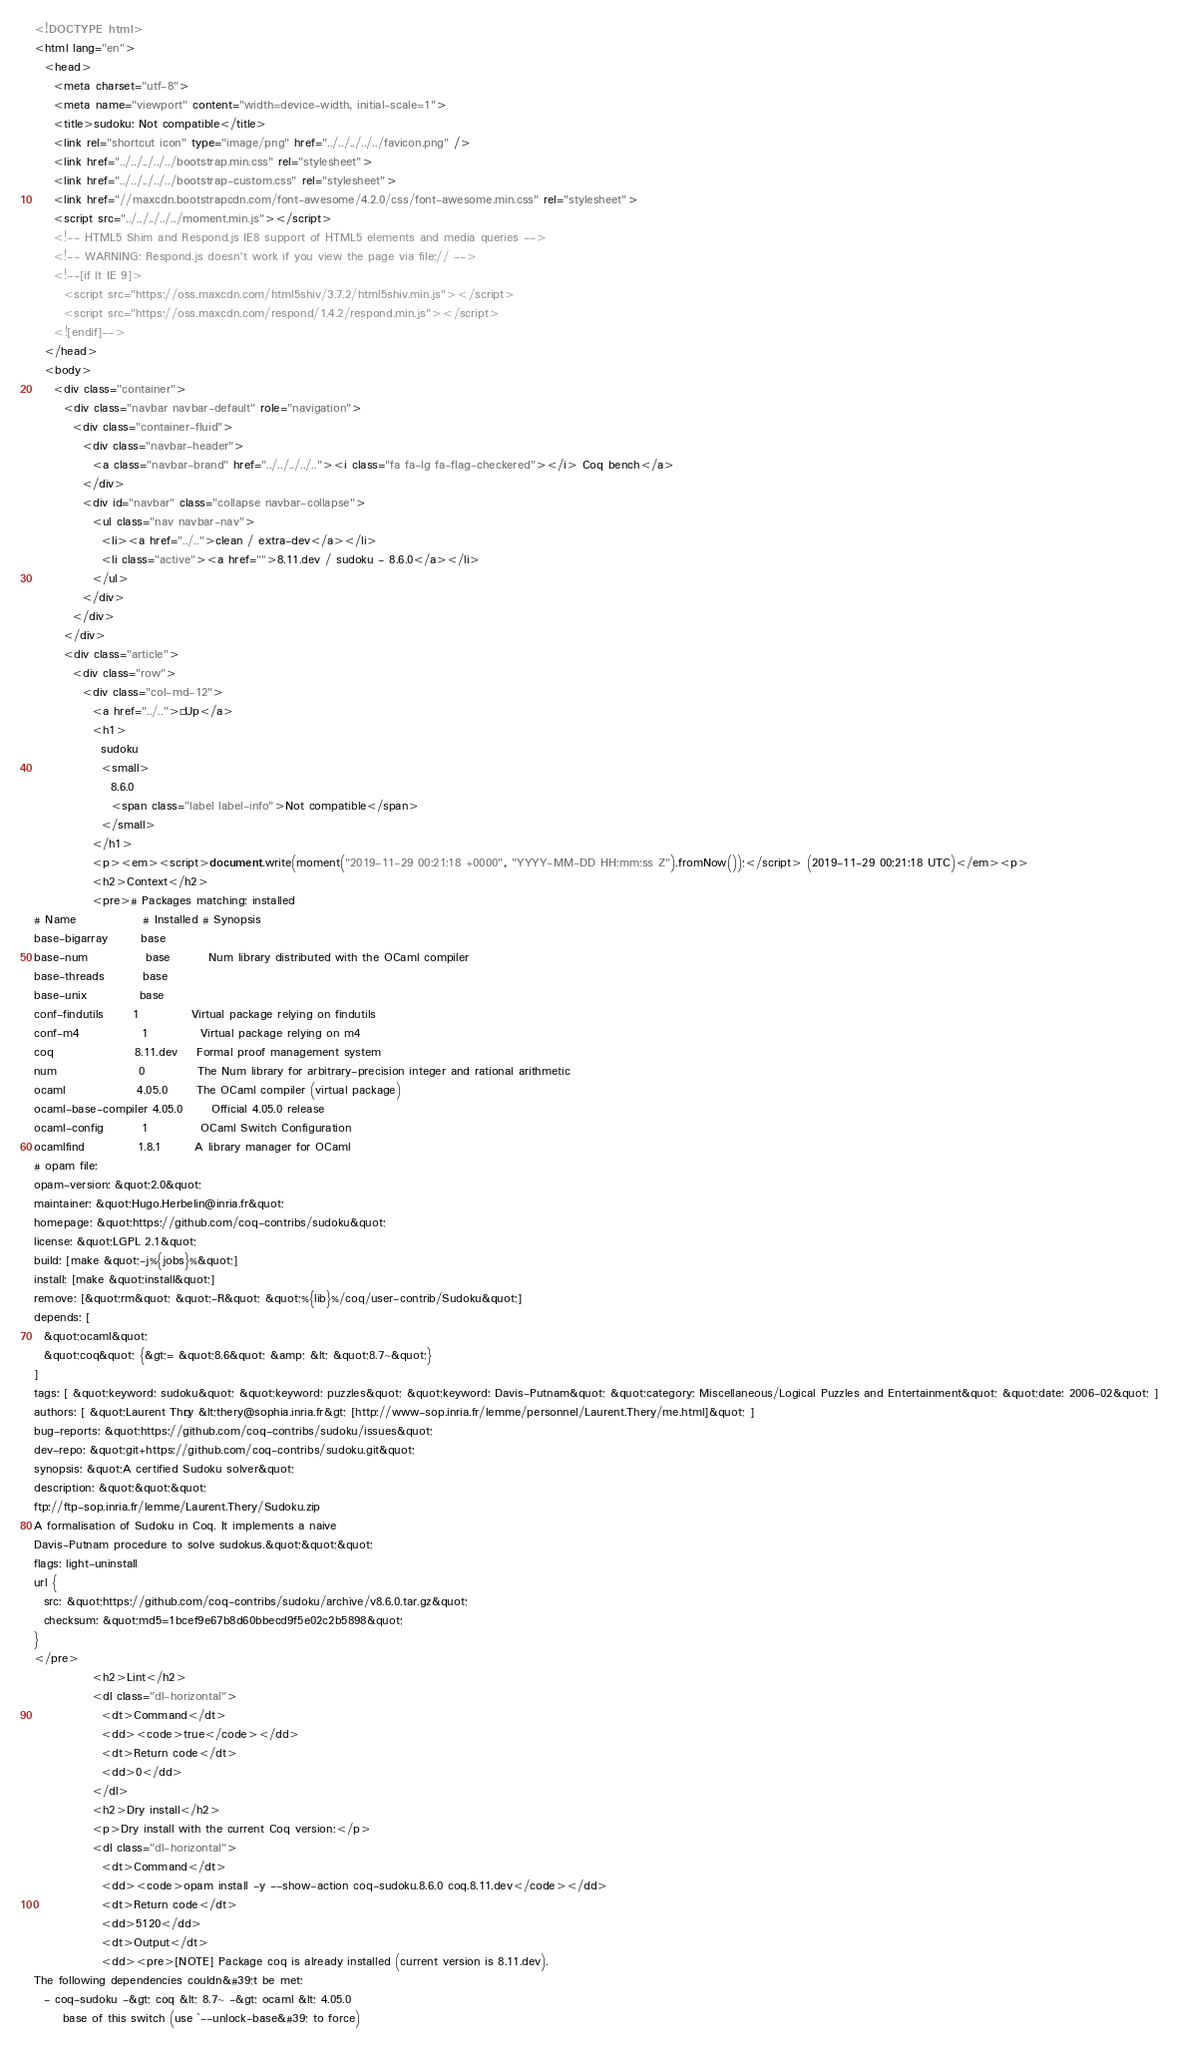Convert code to text. <code><loc_0><loc_0><loc_500><loc_500><_HTML_><!DOCTYPE html>
<html lang="en">
  <head>
    <meta charset="utf-8">
    <meta name="viewport" content="width=device-width, initial-scale=1">
    <title>sudoku: Not compatible</title>
    <link rel="shortcut icon" type="image/png" href="../../../../../favicon.png" />
    <link href="../../../../../bootstrap.min.css" rel="stylesheet">
    <link href="../../../../../bootstrap-custom.css" rel="stylesheet">
    <link href="//maxcdn.bootstrapcdn.com/font-awesome/4.2.0/css/font-awesome.min.css" rel="stylesheet">
    <script src="../../../../../moment.min.js"></script>
    <!-- HTML5 Shim and Respond.js IE8 support of HTML5 elements and media queries -->
    <!-- WARNING: Respond.js doesn't work if you view the page via file:// -->
    <!--[if lt IE 9]>
      <script src="https://oss.maxcdn.com/html5shiv/3.7.2/html5shiv.min.js"></script>
      <script src="https://oss.maxcdn.com/respond/1.4.2/respond.min.js"></script>
    <![endif]-->
  </head>
  <body>
    <div class="container">
      <div class="navbar navbar-default" role="navigation">
        <div class="container-fluid">
          <div class="navbar-header">
            <a class="navbar-brand" href="../../../../.."><i class="fa fa-lg fa-flag-checkered"></i> Coq bench</a>
          </div>
          <div id="navbar" class="collapse navbar-collapse">
            <ul class="nav navbar-nav">
              <li><a href="../..">clean / extra-dev</a></li>
              <li class="active"><a href="">8.11.dev / sudoku - 8.6.0</a></li>
            </ul>
          </div>
        </div>
      </div>
      <div class="article">
        <div class="row">
          <div class="col-md-12">
            <a href="../..">« Up</a>
            <h1>
              sudoku
              <small>
                8.6.0
                <span class="label label-info">Not compatible</span>
              </small>
            </h1>
            <p><em><script>document.write(moment("2019-11-29 00:21:18 +0000", "YYYY-MM-DD HH:mm:ss Z").fromNow());</script> (2019-11-29 00:21:18 UTC)</em><p>
            <h2>Context</h2>
            <pre># Packages matching: installed
# Name              # Installed # Synopsis
base-bigarray       base
base-num            base        Num library distributed with the OCaml compiler
base-threads        base
base-unix           base
conf-findutils      1           Virtual package relying on findutils
conf-m4             1           Virtual package relying on m4
coq                 8.11.dev    Formal proof management system
num                 0           The Num library for arbitrary-precision integer and rational arithmetic
ocaml               4.05.0      The OCaml compiler (virtual package)
ocaml-base-compiler 4.05.0      Official 4.05.0 release
ocaml-config        1           OCaml Switch Configuration
ocamlfind           1.8.1       A library manager for OCaml
# opam file:
opam-version: &quot;2.0&quot;
maintainer: &quot;Hugo.Herbelin@inria.fr&quot;
homepage: &quot;https://github.com/coq-contribs/sudoku&quot;
license: &quot;LGPL 2.1&quot;
build: [make &quot;-j%{jobs}%&quot;]
install: [make &quot;install&quot;]
remove: [&quot;rm&quot; &quot;-R&quot; &quot;%{lib}%/coq/user-contrib/Sudoku&quot;]
depends: [
  &quot;ocaml&quot;
  &quot;coq&quot; {&gt;= &quot;8.6&quot; &amp; &lt; &quot;8.7~&quot;}
]
tags: [ &quot;keyword: sudoku&quot; &quot;keyword: puzzles&quot; &quot;keyword: Davis-Putnam&quot; &quot;category: Miscellaneous/Logical Puzzles and Entertainment&quot; &quot;date: 2006-02&quot; ]
authors: [ &quot;Laurent Théry &lt;thery@sophia.inria.fr&gt; [http://www-sop.inria.fr/lemme/personnel/Laurent.Thery/me.html]&quot; ]
bug-reports: &quot;https://github.com/coq-contribs/sudoku/issues&quot;
dev-repo: &quot;git+https://github.com/coq-contribs/sudoku.git&quot;
synopsis: &quot;A certified Sudoku solver&quot;
description: &quot;&quot;&quot;
ftp://ftp-sop.inria.fr/lemme/Laurent.Thery/Sudoku.zip
A formalisation of Sudoku in Coq. It implements a naive
Davis-Putnam procedure to solve sudokus.&quot;&quot;&quot;
flags: light-uninstall
url {
  src: &quot;https://github.com/coq-contribs/sudoku/archive/v8.6.0.tar.gz&quot;
  checksum: &quot;md5=1bcef9e67b8d60bbecd9f5e02c2b5898&quot;
}
</pre>
            <h2>Lint</h2>
            <dl class="dl-horizontal">
              <dt>Command</dt>
              <dd><code>true</code></dd>
              <dt>Return code</dt>
              <dd>0</dd>
            </dl>
            <h2>Dry install</h2>
            <p>Dry install with the current Coq version:</p>
            <dl class="dl-horizontal">
              <dt>Command</dt>
              <dd><code>opam install -y --show-action coq-sudoku.8.6.0 coq.8.11.dev</code></dd>
              <dt>Return code</dt>
              <dd>5120</dd>
              <dt>Output</dt>
              <dd><pre>[NOTE] Package coq is already installed (current version is 8.11.dev).
The following dependencies couldn&#39;t be met:
  - coq-sudoku -&gt; coq &lt; 8.7~ -&gt; ocaml &lt; 4.05.0
      base of this switch (use `--unlock-base&#39; to force)</code> 